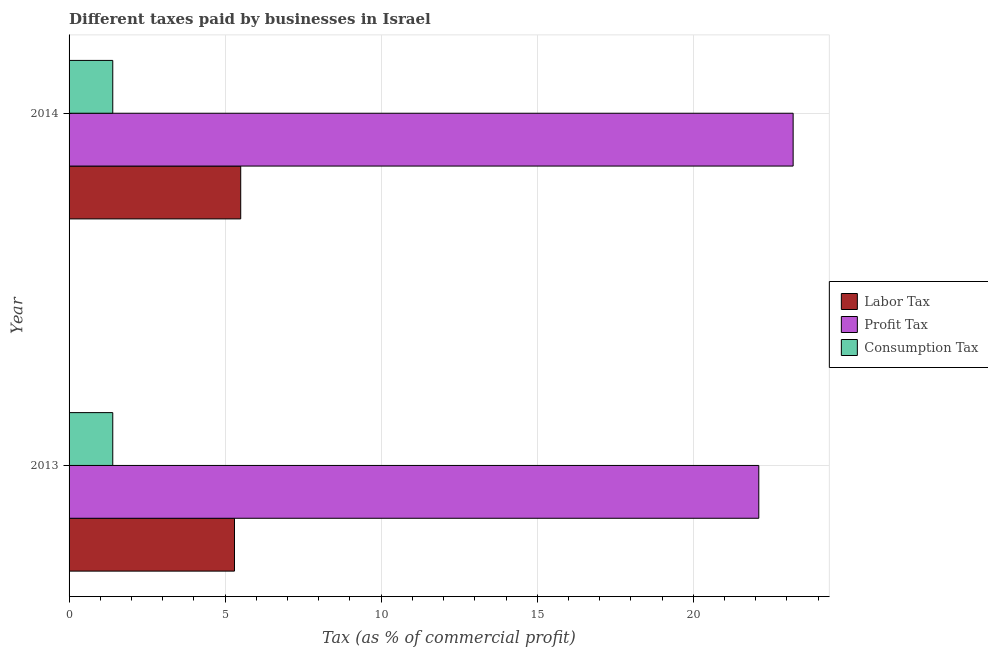How many different coloured bars are there?
Ensure brevity in your answer.  3. How many groups of bars are there?
Keep it short and to the point. 2. How many bars are there on the 1st tick from the top?
Keep it short and to the point. 3. In how many cases, is the number of bars for a given year not equal to the number of legend labels?
Your answer should be compact. 0. What is the percentage of consumption tax in 2014?
Your answer should be compact. 1.4. Across all years, what is the maximum percentage of consumption tax?
Offer a terse response. 1.4. Across all years, what is the minimum percentage of profit tax?
Keep it short and to the point. 22.1. In which year was the percentage of labor tax maximum?
Make the answer very short. 2014. In which year was the percentage of consumption tax minimum?
Give a very brief answer. 2013. What is the total percentage of profit tax in the graph?
Your response must be concise. 45.3. What is the difference between the percentage of profit tax in 2013 and the percentage of consumption tax in 2014?
Make the answer very short. 20.7. In the year 2013, what is the difference between the percentage of profit tax and percentage of consumption tax?
Give a very brief answer. 20.7. What is the ratio of the percentage of labor tax in 2013 to that in 2014?
Provide a succinct answer. 0.96. In how many years, is the percentage of labor tax greater than the average percentage of labor tax taken over all years?
Your response must be concise. 1. What does the 3rd bar from the top in 2013 represents?
Provide a succinct answer. Labor Tax. What does the 1st bar from the bottom in 2013 represents?
Your response must be concise. Labor Tax. How many bars are there?
Offer a terse response. 6. Are all the bars in the graph horizontal?
Your response must be concise. Yes. Are the values on the major ticks of X-axis written in scientific E-notation?
Provide a succinct answer. No. Does the graph contain any zero values?
Give a very brief answer. No. Where does the legend appear in the graph?
Provide a short and direct response. Center right. What is the title of the graph?
Your answer should be compact. Different taxes paid by businesses in Israel. Does "Travel services" appear as one of the legend labels in the graph?
Keep it short and to the point. No. What is the label or title of the X-axis?
Keep it short and to the point. Tax (as % of commercial profit). What is the Tax (as % of commercial profit) of Profit Tax in 2013?
Provide a short and direct response. 22.1. What is the Tax (as % of commercial profit) of Profit Tax in 2014?
Your answer should be very brief. 23.2. What is the Tax (as % of commercial profit) of Consumption Tax in 2014?
Keep it short and to the point. 1.4. Across all years, what is the maximum Tax (as % of commercial profit) in Profit Tax?
Offer a terse response. 23.2. Across all years, what is the minimum Tax (as % of commercial profit) in Labor Tax?
Your answer should be compact. 5.3. Across all years, what is the minimum Tax (as % of commercial profit) of Profit Tax?
Ensure brevity in your answer.  22.1. What is the total Tax (as % of commercial profit) of Labor Tax in the graph?
Ensure brevity in your answer.  10.8. What is the total Tax (as % of commercial profit) in Profit Tax in the graph?
Offer a very short reply. 45.3. What is the total Tax (as % of commercial profit) of Consumption Tax in the graph?
Provide a short and direct response. 2.8. What is the difference between the Tax (as % of commercial profit) of Profit Tax in 2013 and that in 2014?
Your answer should be very brief. -1.1. What is the difference between the Tax (as % of commercial profit) in Consumption Tax in 2013 and that in 2014?
Your answer should be compact. 0. What is the difference between the Tax (as % of commercial profit) in Labor Tax in 2013 and the Tax (as % of commercial profit) in Profit Tax in 2014?
Offer a very short reply. -17.9. What is the difference between the Tax (as % of commercial profit) in Labor Tax in 2013 and the Tax (as % of commercial profit) in Consumption Tax in 2014?
Your answer should be very brief. 3.9. What is the difference between the Tax (as % of commercial profit) of Profit Tax in 2013 and the Tax (as % of commercial profit) of Consumption Tax in 2014?
Keep it short and to the point. 20.7. What is the average Tax (as % of commercial profit) in Profit Tax per year?
Provide a short and direct response. 22.65. What is the average Tax (as % of commercial profit) of Consumption Tax per year?
Give a very brief answer. 1.4. In the year 2013, what is the difference between the Tax (as % of commercial profit) of Labor Tax and Tax (as % of commercial profit) of Profit Tax?
Your response must be concise. -16.8. In the year 2013, what is the difference between the Tax (as % of commercial profit) of Profit Tax and Tax (as % of commercial profit) of Consumption Tax?
Give a very brief answer. 20.7. In the year 2014, what is the difference between the Tax (as % of commercial profit) of Labor Tax and Tax (as % of commercial profit) of Profit Tax?
Your answer should be compact. -17.7. In the year 2014, what is the difference between the Tax (as % of commercial profit) of Profit Tax and Tax (as % of commercial profit) of Consumption Tax?
Your response must be concise. 21.8. What is the ratio of the Tax (as % of commercial profit) in Labor Tax in 2013 to that in 2014?
Offer a very short reply. 0.96. What is the ratio of the Tax (as % of commercial profit) in Profit Tax in 2013 to that in 2014?
Provide a succinct answer. 0.95. What is the difference between the highest and the second highest Tax (as % of commercial profit) in Labor Tax?
Ensure brevity in your answer.  0.2. What is the difference between the highest and the second highest Tax (as % of commercial profit) of Consumption Tax?
Offer a very short reply. 0. What is the difference between the highest and the lowest Tax (as % of commercial profit) in Labor Tax?
Your answer should be very brief. 0.2. What is the difference between the highest and the lowest Tax (as % of commercial profit) of Profit Tax?
Your answer should be compact. 1.1. 